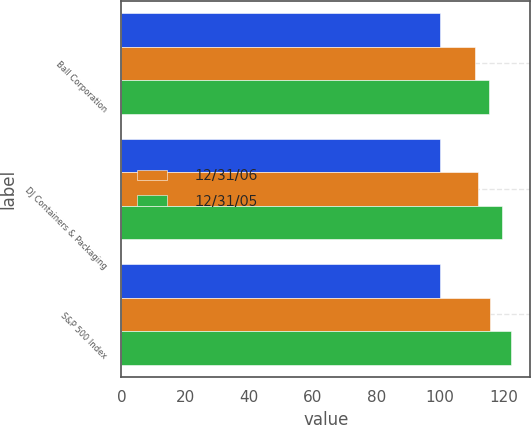Convert chart. <chart><loc_0><loc_0><loc_500><loc_500><stacked_bar_chart><ecel><fcel>Ball Corporation<fcel>DJ Containers & Packaging<fcel>S&P 500 Index<nl><fcel>nan<fcel>100<fcel>100<fcel>100<nl><fcel>12/31/06<fcel>110.86<fcel>112.09<fcel>115.8<nl><fcel>12/31/05<fcel>115.36<fcel>119.63<fcel>122.16<nl></chart> 